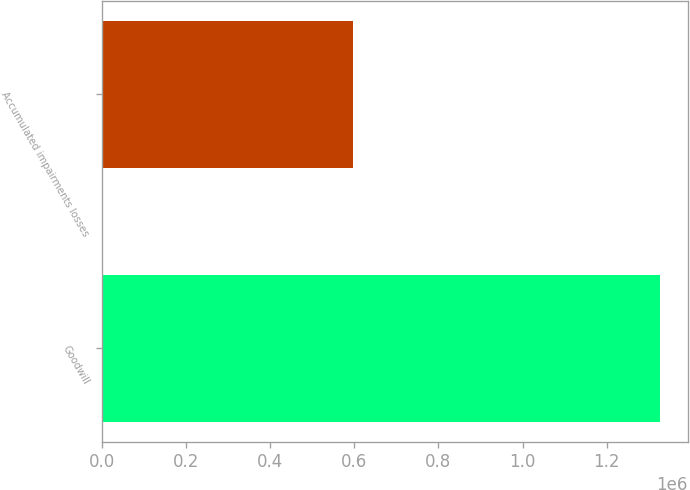Convert chart to OTSL. <chart><loc_0><loc_0><loc_500><loc_500><bar_chart><fcel>Goodwill<fcel>Accumulated impairments losses<nl><fcel>1.32715e+06<fcel>596363<nl></chart> 